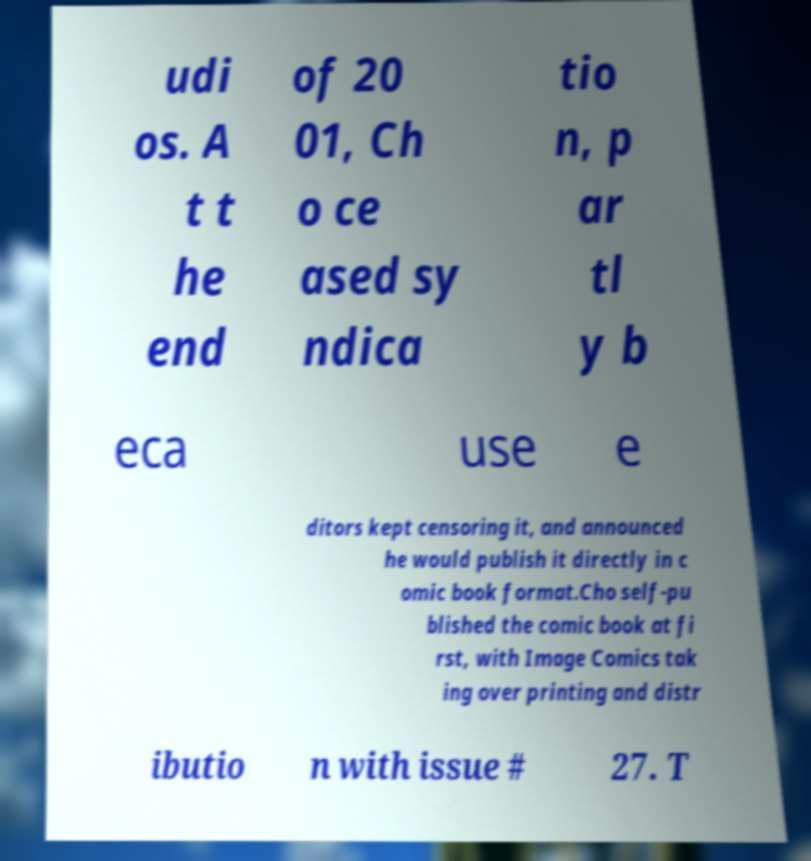I need the written content from this picture converted into text. Can you do that? udi os. A t t he end of 20 01, Ch o ce ased sy ndica tio n, p ar tl y b eca use e ditors kept censoring it, and announced he would publish it directly in c omic book format.Cho self-pu blished the comic book at fi rst, with Image Comics tak ing over printing and distr ibutio n with issue # 27. T 